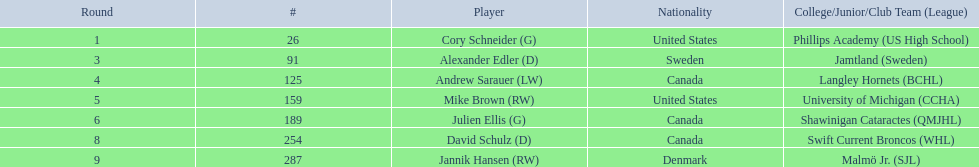Who are the competitors? Cory Schneider (G), Alexander Edler (D), Andrew Sarauer (LW), Mike Brown (RW), Julien Ellis (G), David Schulz (D), Jannik Hansen (RW). Of these, who originates from denmark? Jannik Hansen (RW). 